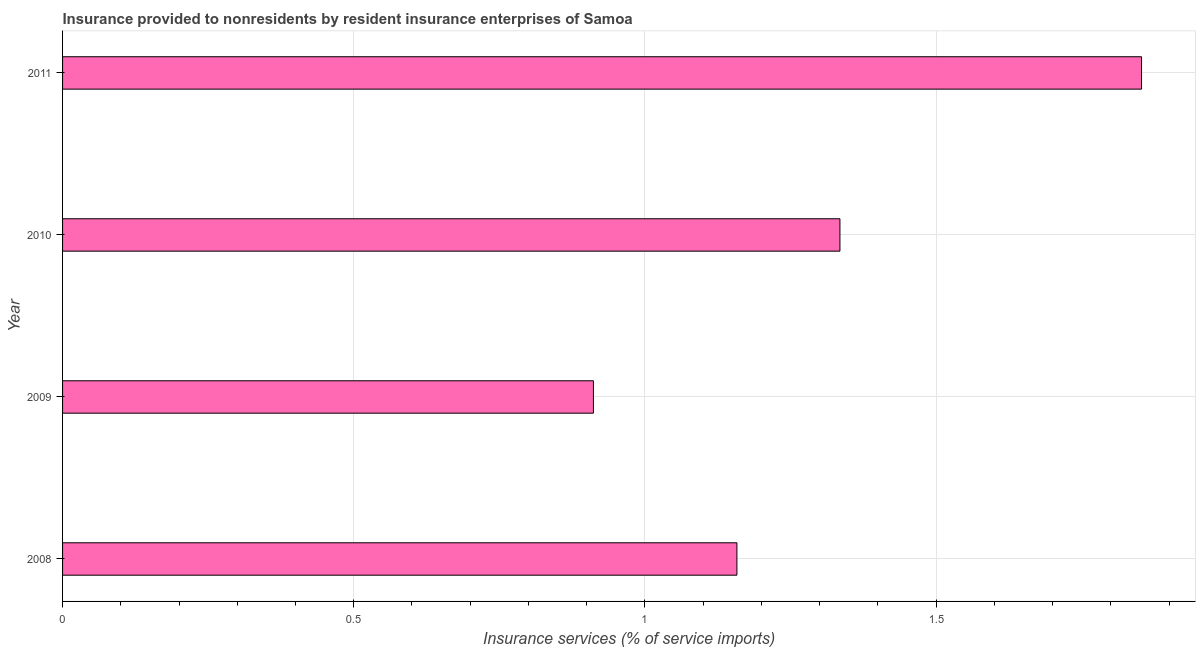Does the graph contain grids?
Keep it short and to the point. Yes. What is the title of the graph?
Offer a very short reply. Insurance provided to nonresidents by resident insurance enterprises of Samoa. What is the label or title of the X-axis?
Provide a short and direct response. Insurance services (% of service imports). What is the insurance and financial services in 2011?
Your answer should be very brief. 1.85. Across all years, what is the maximum insurance and financial services?
Offer a very short reply. 1.85. Across all years, what is the minimum insurance and financial services?
Give a very brief answer. 0.91. In which year was the insurance and financial services maximum?
Provide a short and direct response. 2011. What is the sum of the insurance and financial services?
Offer a very short reply. 5.26. What is the difference between the insurance and financial services in 2009 and 2011?
Offer a terse response. -0.94. What is the average insurance and financial services per year?
Ensure brevity in your answer.  1.31. What is the median insurance and financial services?
Your answer should be compact. 1.25. Do a majority of the years between 2009 and 2011 (inclusive) have insurance and financial services greater than 0.2 %?
Offer a terse response. Yes. What is the ratio of the insurance and financial services in 2009 to that in 2011?
Offer a terse response. 0.49. Is the insurance and financial services in 2008 less than that in 2009?
Keep it short and to the point. No. Is the difference between the insurance and financial services in 2009 and 2010 greater than the difference between any two years?
Ensure brevity in your answer.  No. What is the difference between the highest and the second highest insurance and financial services?
Keep it short and to the point. 0.52. Is the sum of the insurance and financial services in 2008 and 2009 greater than the maximum insurance and financial services across all years?
Your answer should be very brief. Yes. What is the difference between the highest and the lowest insurance and financial services?
Ensure brevity in your answer.  0.94. In how many years, is the insurance and financial services greater than the average insurance and financial services taken over all years?
Keep it short and to the point. 2. How many bars are there?
Give a very brief answer. 4. Are all the bars in the graph horizontal?
Your answer should be very brief. Yes. How many years are there in the graph?
Give a very brief answer. 4. What is the Insurance services (% of service imports) in 2008?
Your response must be concise. 1.16. What is the Insurance services (% of service imports) in 2009?
Make the answer very short. 0.91. What is the Insurance services (% of service imports) in 2010?
Your answer should be very brief. 1.33. What is the Insurance services (% of service imports) in 2011?
Your answer should be compact. 1.85. What is the difference between the Insurance services (% of service imports) in 2008 and 2009?
Provide a succinct answer. 0.25. What is the difference between the Insurance services (% of service imports) in 2008 and 2010?
Your answer should be compact. -0.18. What is the difference between the Insurance services (% of service imports) in 2008 and 2011?
Keep it short and to the point. -0.69. What is the difference between the Insurance services (% of service imports) in 2009 and 2010?
Give a very brief answer. -0.42. What is the difference between the Insurance services (% of service imports) in 2009 and 2011?
Give a very brief answer. -0.94. What is the difference between the Insurance services (% of service imports) in 2010 and 2011?
Your answer should be compact. -0.52. What is the ratio of the Insurance services (% of service imports) in 2008 to that in 2009?
Provide a succinct answer. 1.27. What is the ratio of the Insurance services (% of service imports) in 2008 to that in 2010?
Give a very brief answer. 0.87. What is the ratio of the Insurance services (% of service imports) in 2009 to that in 2010?
Your response must be concise. 0.68. What is the ratio of the Insurance services (% of service imports) in 2009 to that in 2011?
Keep it short and to the point. 0.49. What is the ratio of the Insurance services (% of service imports) in 2010 to that in 2011?
Provide a short and direct response. 0.72. 